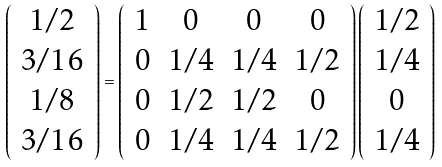Convert formula to latex. <formula><loc_0><loc_0><loc_500><loc_500>\left ( \begin{array} { c } 1 / 2 \\ 3 / 1 6 \\ 1 / 8 \\ 3 / 1 6 \end{array} \right ) = \left ( \begin{array} { c c c c } 1 & 0 & 0 & 0 \\ 0 & 1 / 4 & 1 / 4 & 1 / 2 \\ 0 & 1 / 2 & 1 / 2 & 0 \\ 0 & 1 / 4 & 1 / 4 & 1 / 2 \end{array} \right ) \left ( \begin{array} { c } 1 / 2 \\ 1 / 4 \\ 0 \\ 1 / 4 \end{array} \right )</formula> 